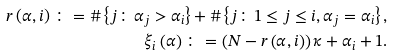<formula> <loc_0><loc_0><loc_500><loc_500>r \left ( \alpha , i \right ) \colon = \# \left \{ j \colon \alpha _ { j } > \alpha _ { i } \right \} + \# \left \{ j \colon 1 \leq j \leq i , \alpha _ { j } = \alpha _ { i } \right \} , \\ \xi _ { i } \left ( \alpha \right ) \colon = \left ( N - r \left ( \alpha , i \right ) \right ) \kappa + \alpha _ { i } + 1 .</formula> 